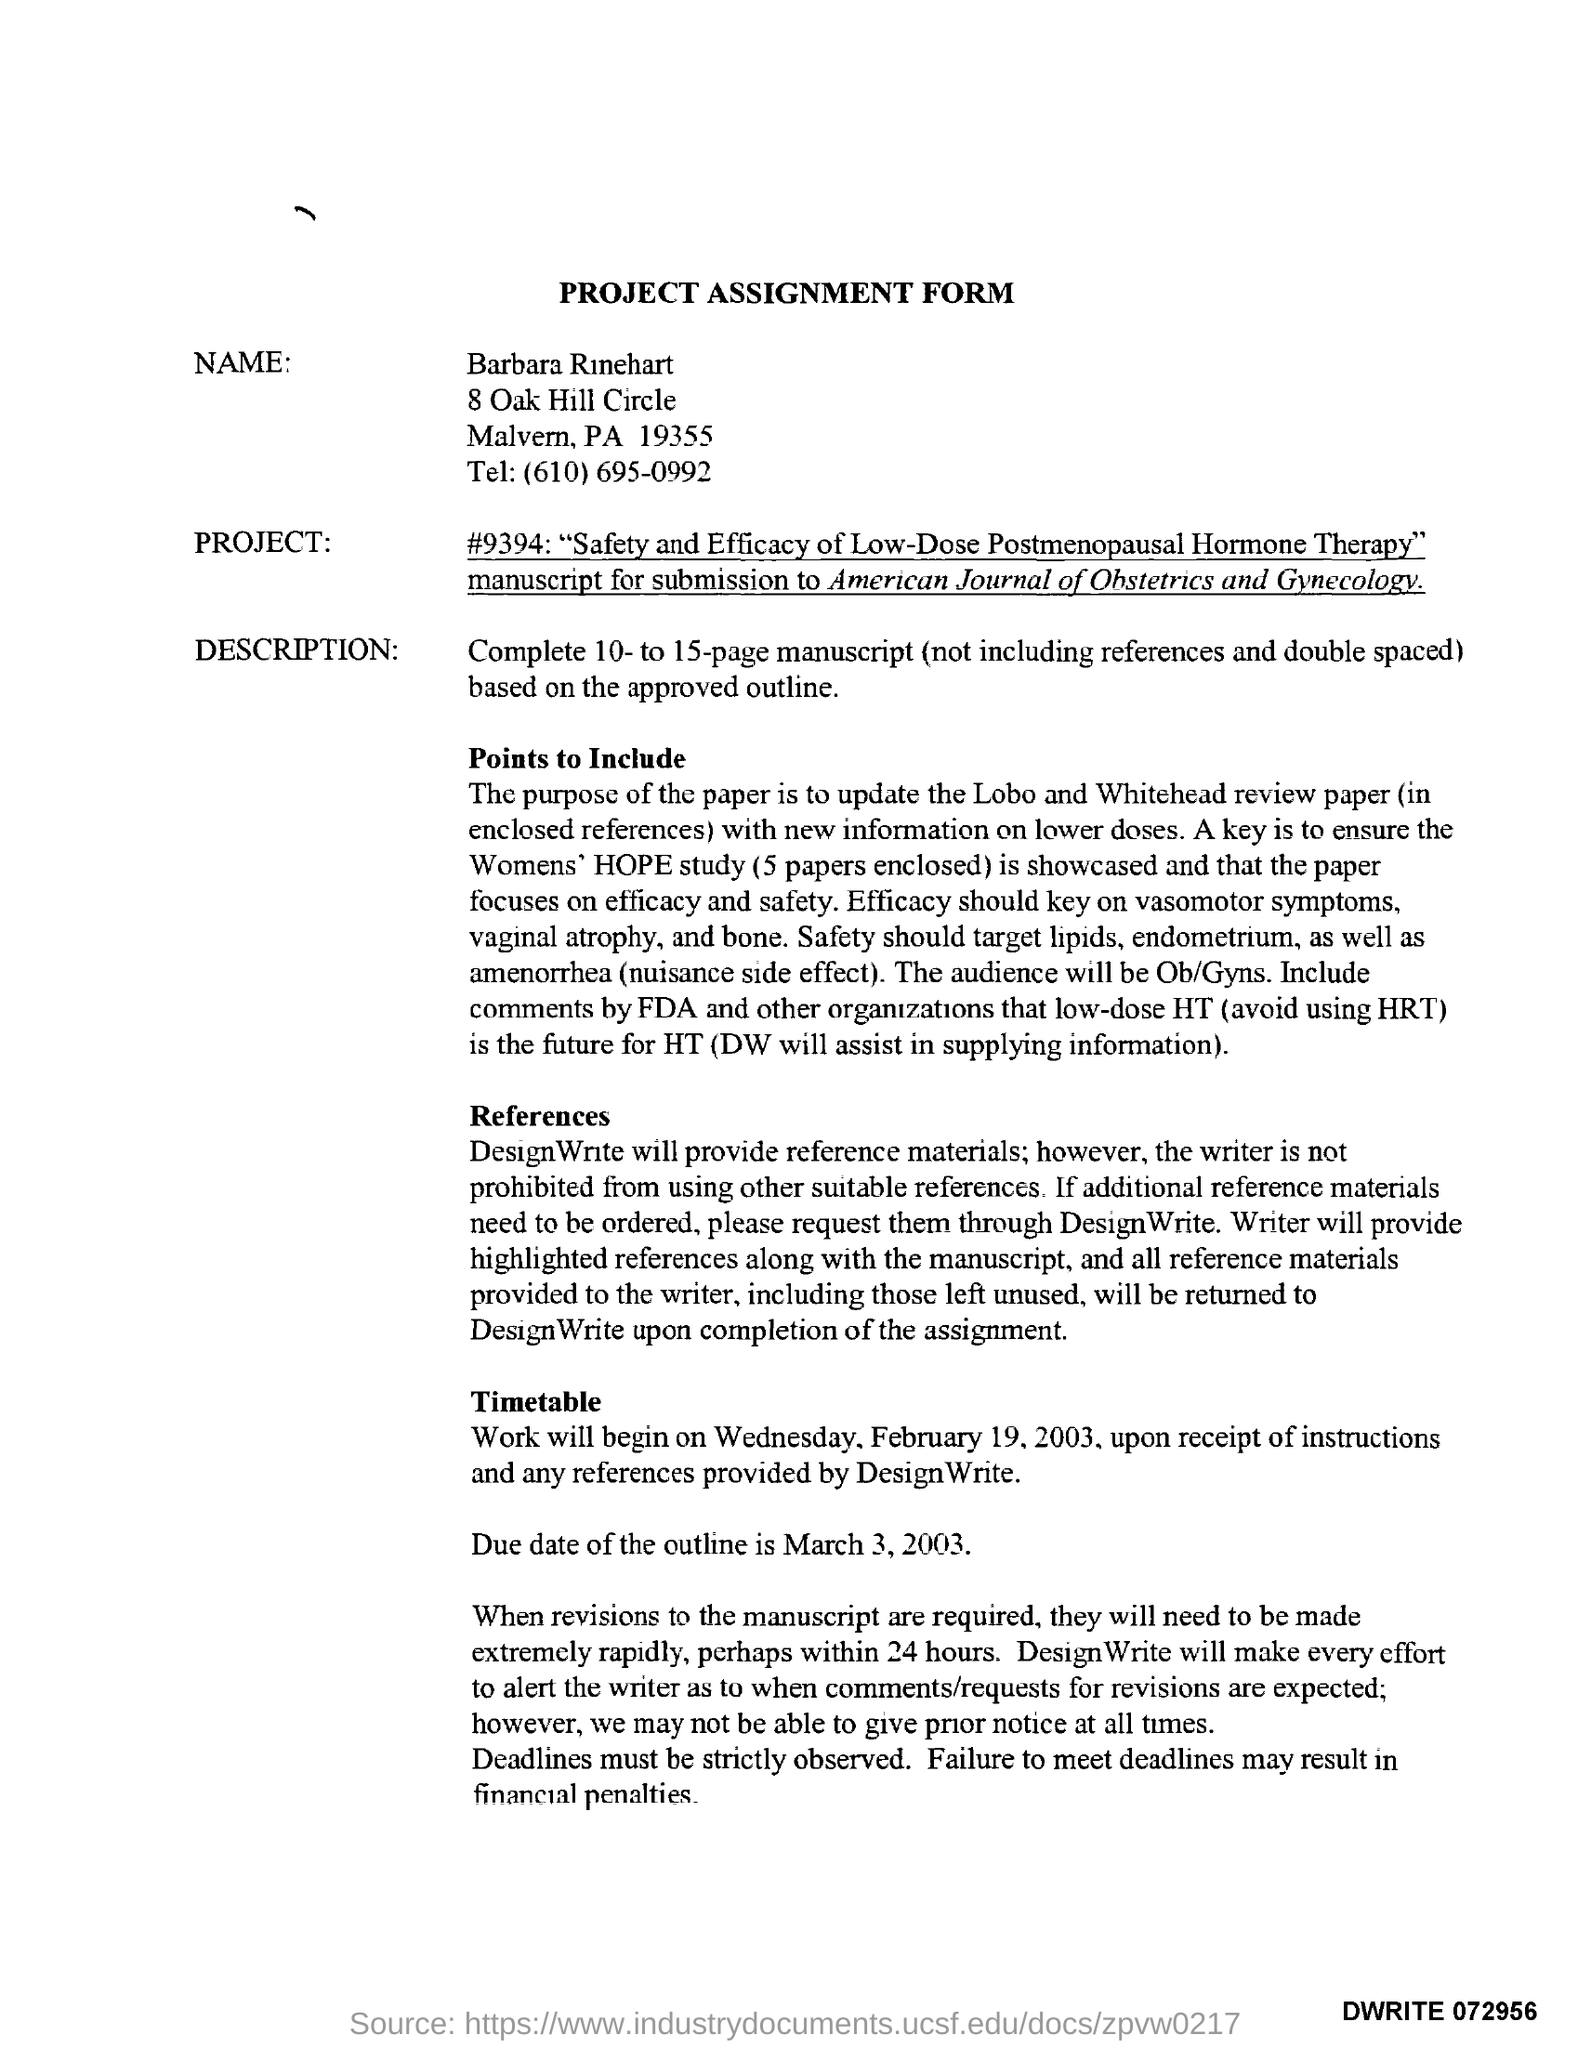Draw attention to some important aspects in this diagram. The due date for the outline mentioned in the assignment form is March 3, 2003. 